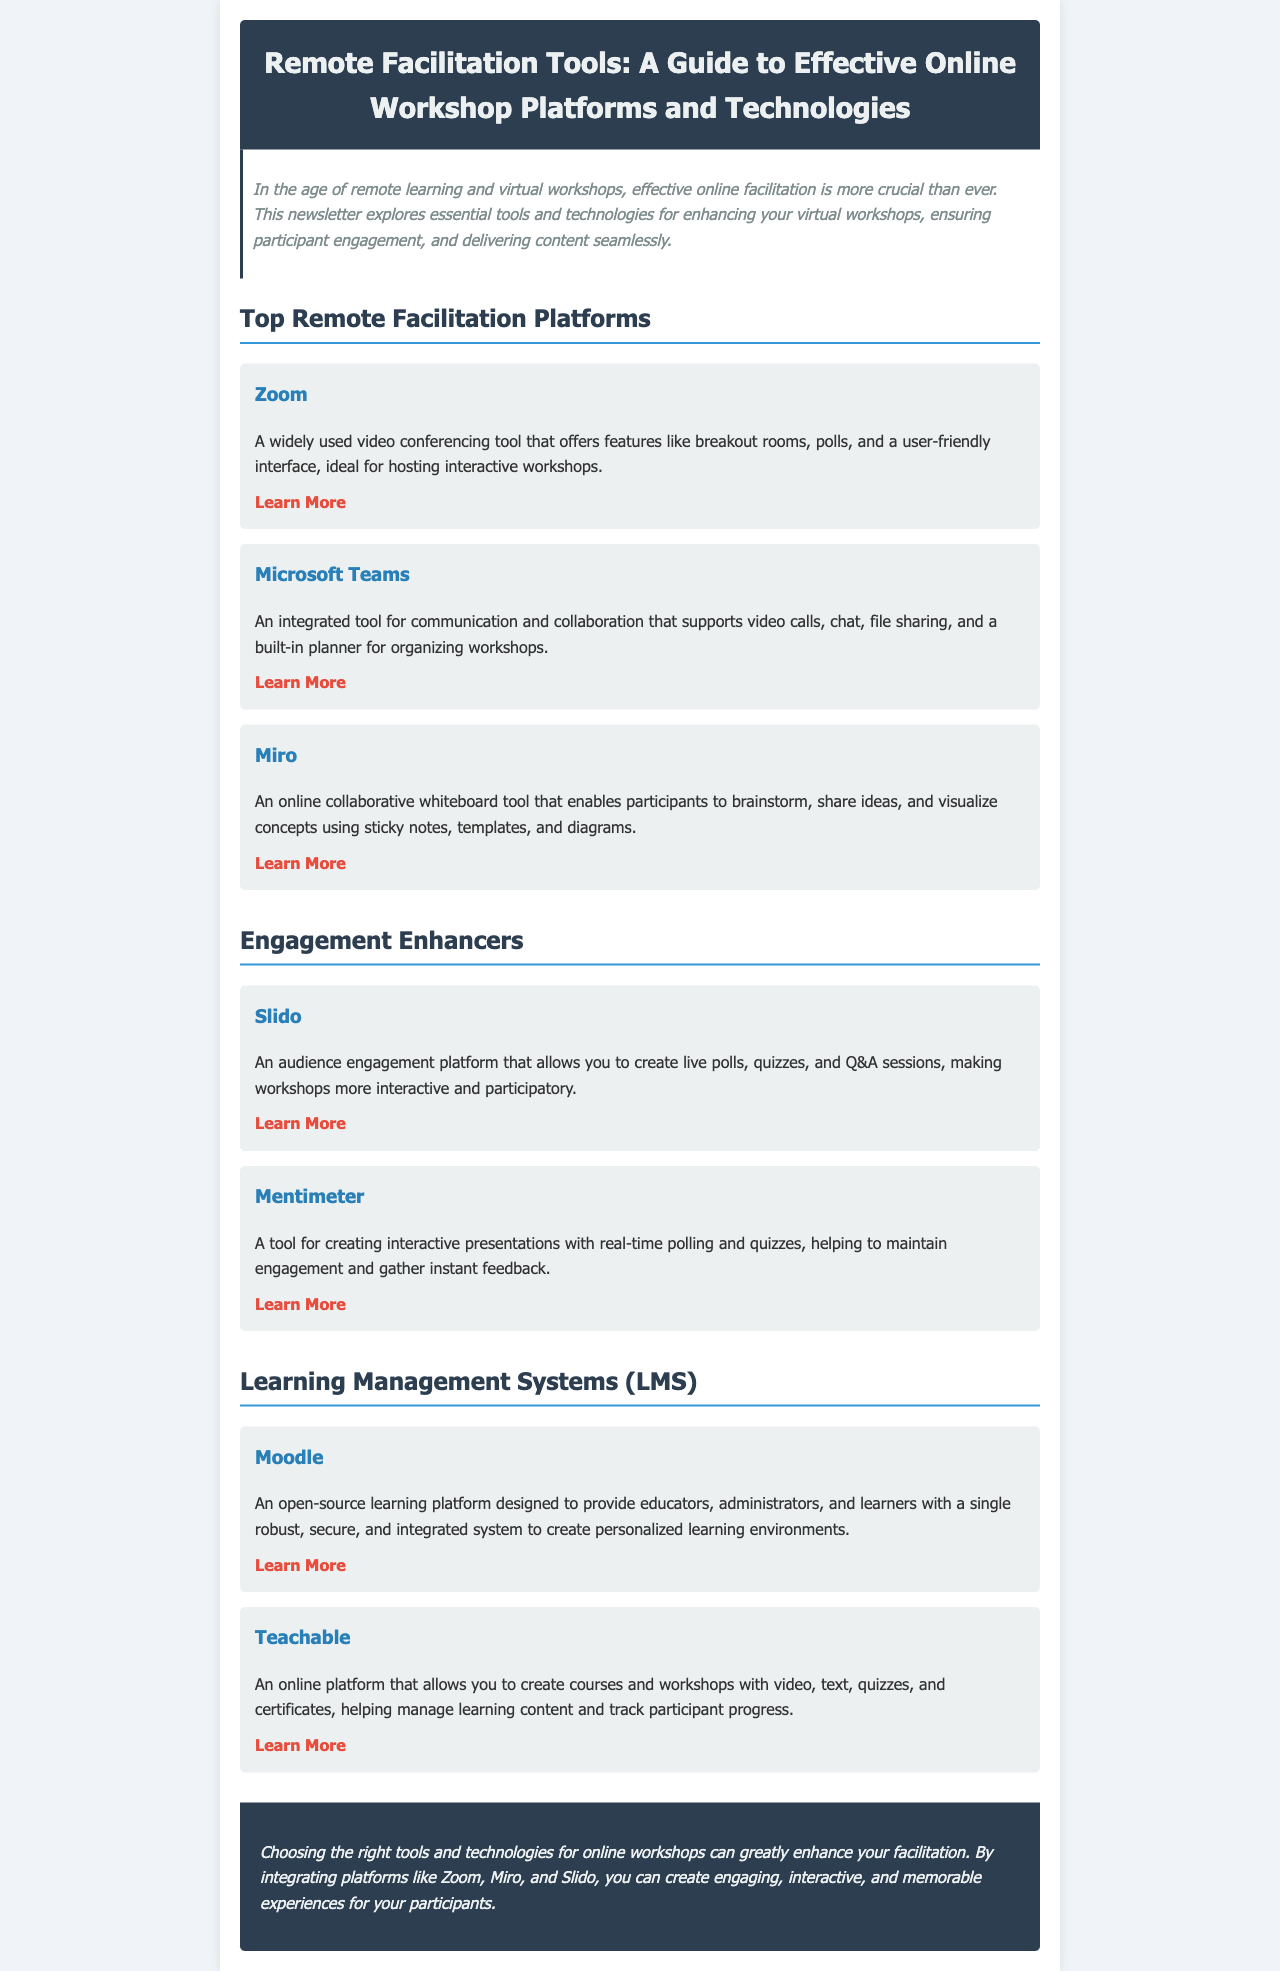What is the title of the newsletter? The title of the newsletter is presented in the header section at the top of the document.
Answer: Remote Facilitation Tools: A Guide to Effective Online Workshop Platforms and Technologies How many engagement enhancers are mentioned? The number of engagement enhancers is the count of the tools listed under the "Engagement Enhancers" section.
Answer: 2 What tool is described as an online collaborative whiteboard? The tool described as an online collaborative whiteboard is mentioned under the "Top Remote Facilitation Platforms" section.
Answer: Miro Which platform allows for real-time polling in presentations? The platform that facilitates real-time polling is listed in the "Engagement Enhancers" section.
Answer: Mentimeter What is the main purpose of Moodle? The main purpose of Moodle is detailed in the "Learning Management Systems (LMS)" section regarding personalized learning environments.
Answer: Provide personalized learning environments Which tool offers breakout rooms as a feature? The tool offering breakout rooms is mentioned in the "Top Remote Facilitation Platforms" section.
Answer: Zoom How many total remote facilitation platforms are listed? The total number of platforms is the sum of tools listed in the "Top Remote Facilitation Platforms" section.
Answer: 3 What is the color of the conclusion section's background? The background color of the conclusion section is specified in the styling aspect of the document.
Answer: #2c3e50 